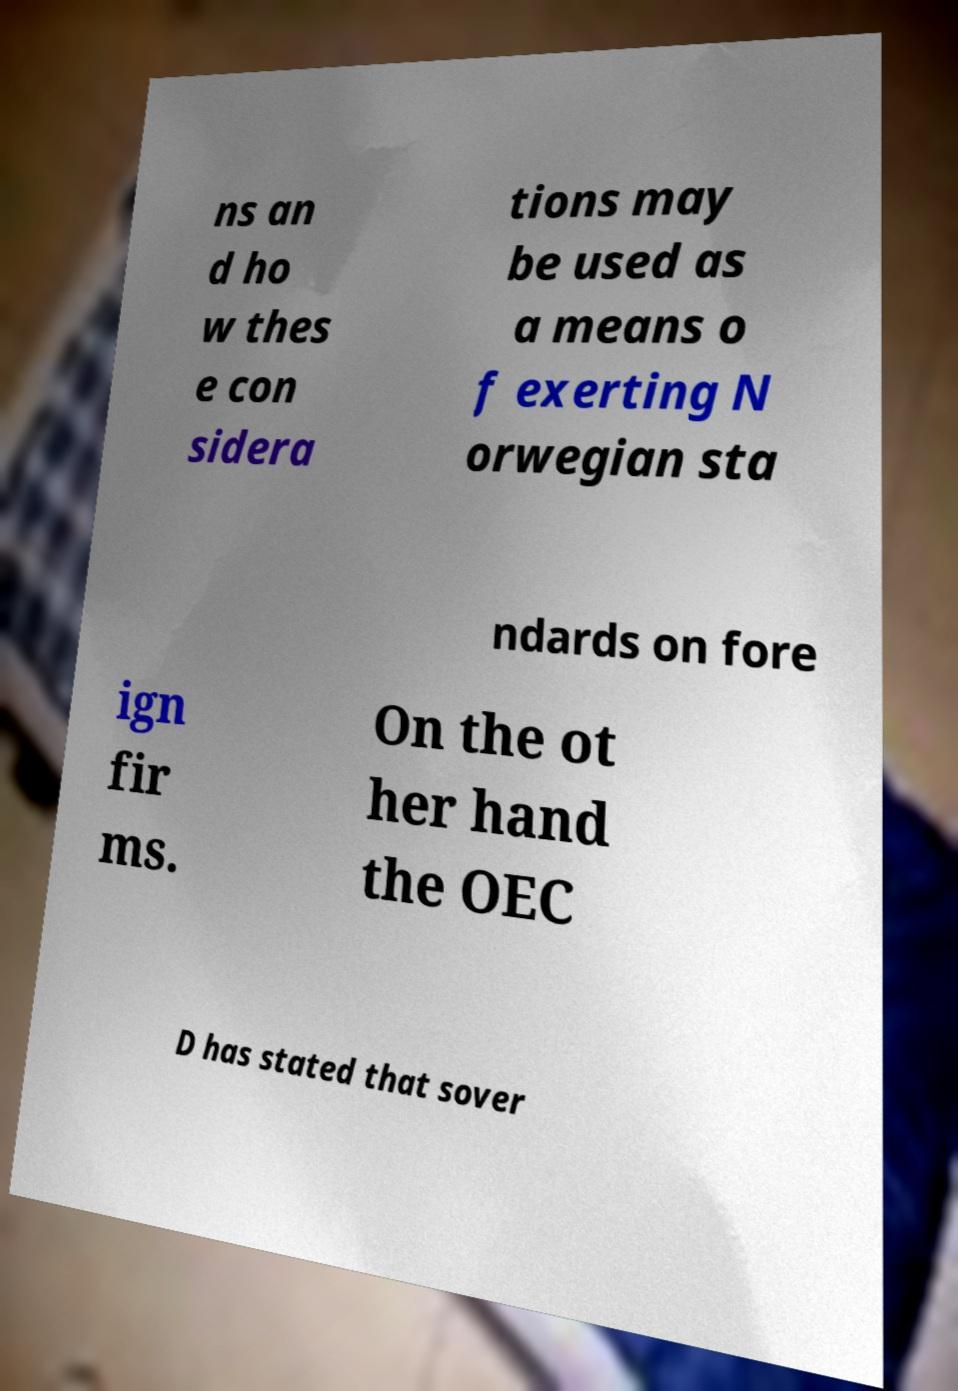Can you accurately transcribe the text from the provided image for me? ns an d ho w thes e con sidera tions may be used as a means o f exerting N orwegian sta ndards on fore ign fir ms. On the ot her hand the OEC D has stated that sover 